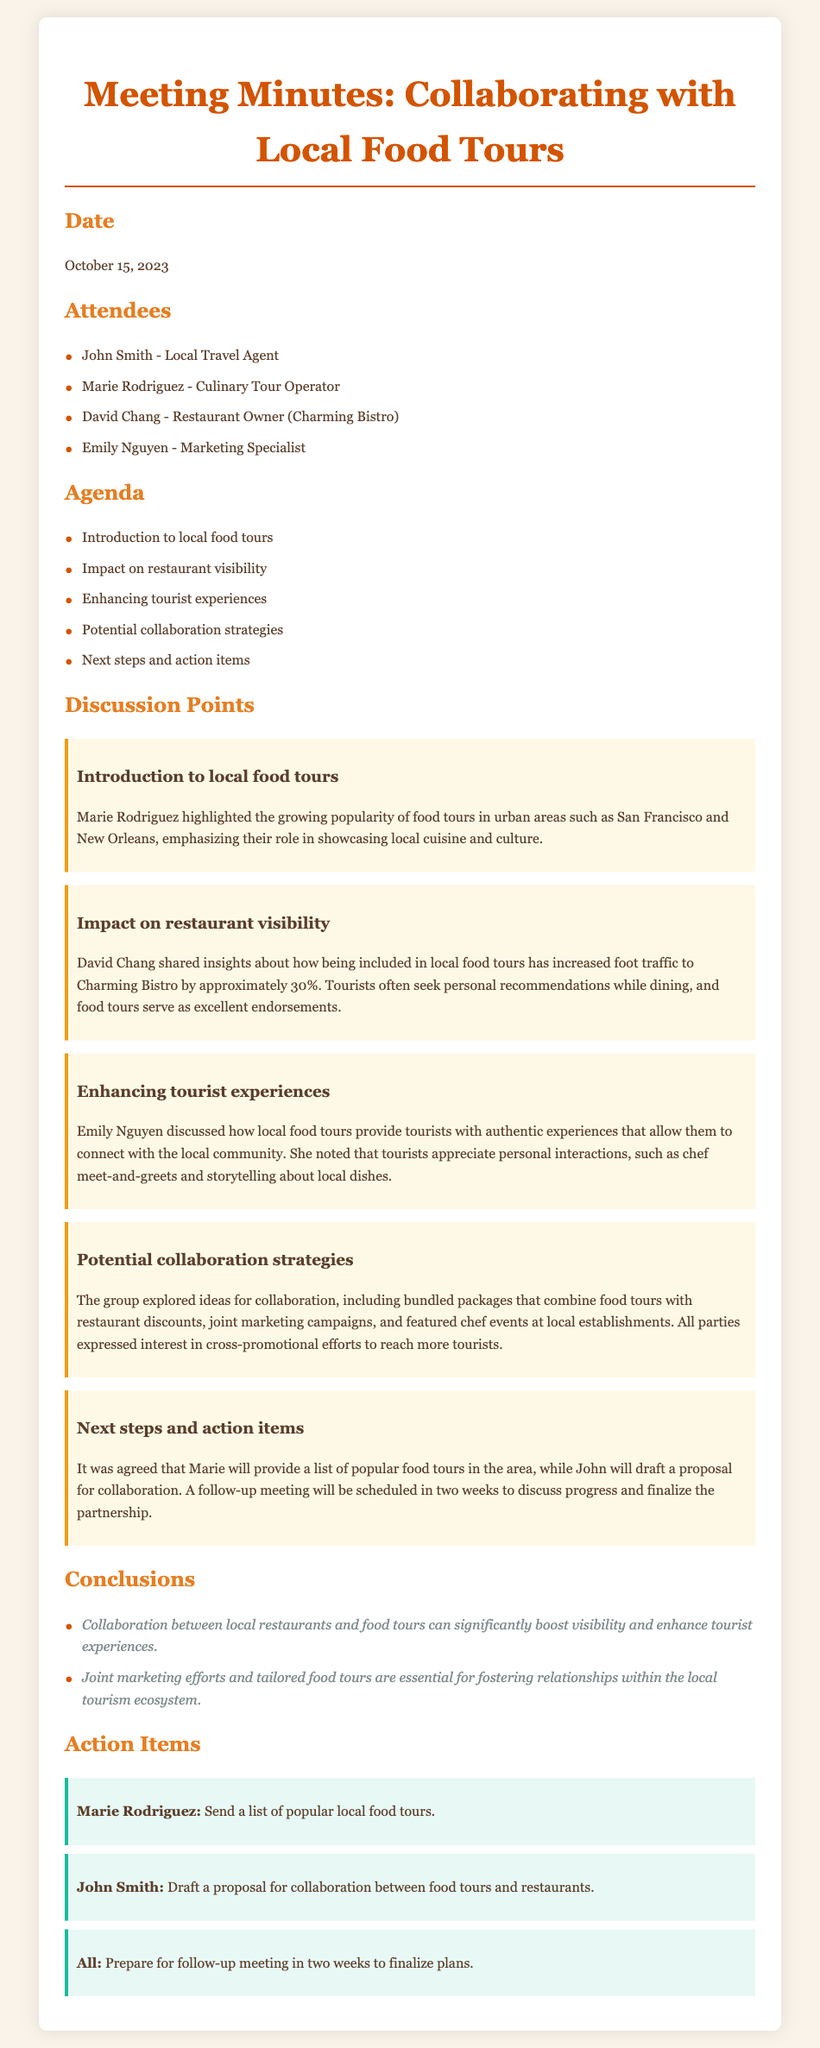What is the date of the meeting? The date of the meeting is specified at the beginning of the document under the Date section.
Answer: October 15, 2023 Who highlighted the popularity of food tours? The document states that Marie Rodriguez highlighted the popularity of food tours during the discussion.
Answer: Marie Rodriguez What percentage did foot traffic increase at Charming Bistro? David Chang mentions the increase in foot traffic attributed to food tours in his discussion point.
Answer: Approximately 30% What is one method suggested for collaboration? The document lists several potential collaboration strategies, including bundled packages as a method.
Answer: Bundled packages Who is responsible for drafting the proposal for collaboration? The action items section indicates that John Smith is tasked with drafting the proposal.
Answer: John Smith What theme was discussed regarding enhancing tourist experiences? Emily Nguyen's discussion focused on how food tours provide tourists authentic connections to the local community.
Answer: Authentic experiences How long until the follow-up meeting is scheduled? The document mentions that a follow-up meeting will be scheduled in two weeks.
Answer: Two weeks What is emphasized as important for relationships within the local tourism ecosystem? The conclusions section highlights the necessity of joint marketing efforts for strengthening relationships.
Answer: Joint marketing efforts 